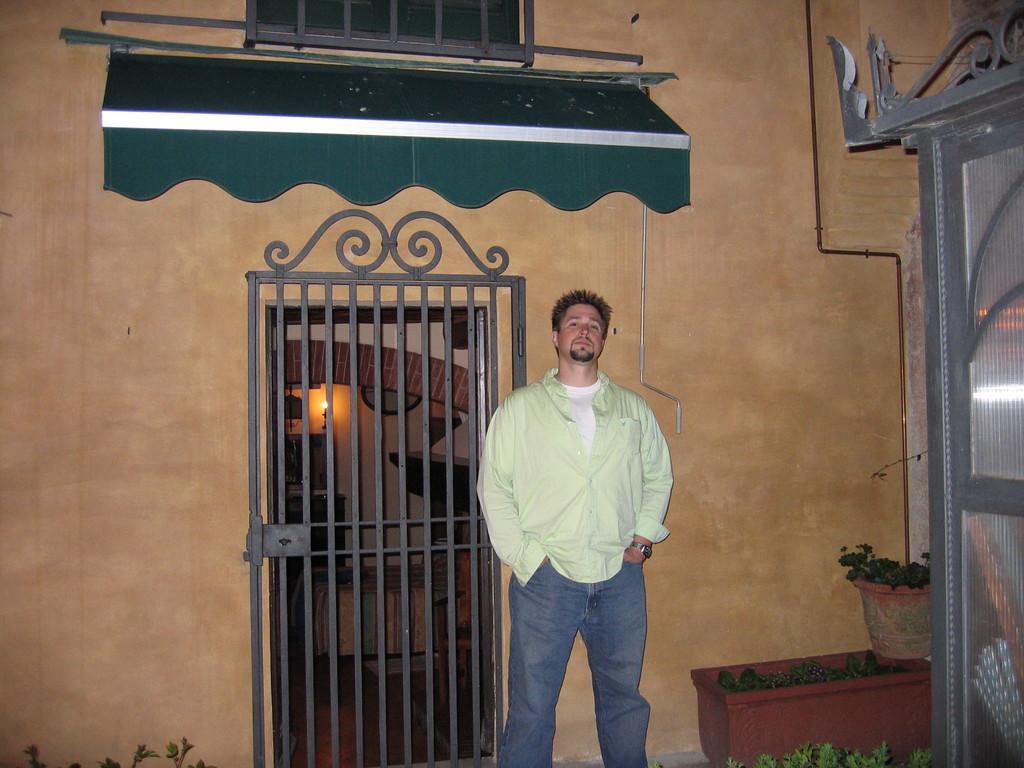Please provide a concise description of this image. In this picture i can see a man is standing on the ground. The man is wearing shirt, pant and watch. In the background i can see wall and other objects. On the right side i can see plant pots. 